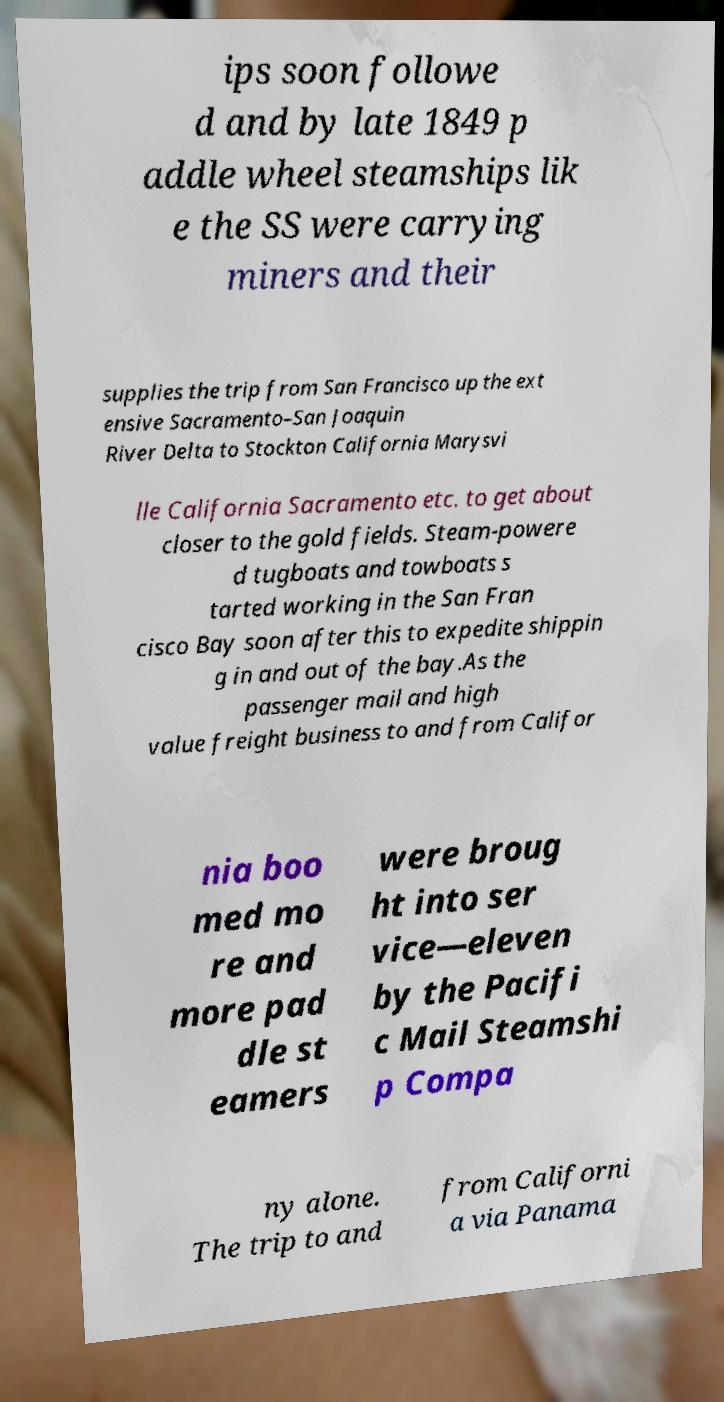Please read and relay the text visible in this image. What does it say? ips soon followe d and by late 1849 p addle wheel steamships lik e the SS were carrying miners and their supplies the trip from San Francisco up the ext ensive Sacramento–San Joaquin River Delta to Stockton California Marysvi lle California Sacramento etc. to get about closer to the gold fields. Steam-powere d tugboats and towboats s tarted working in the San Fran cisco Bay soon after this to expedite shippin g in and out of the bay.As the passenger mail and high value freight business to and from Califor nia boo med mo re and more pad dle st eamers were broug ht into ser vice—eleven by the Pacifi c Mail Steamshi p Compa ny alone. The trip to and from Californi a via Panama 